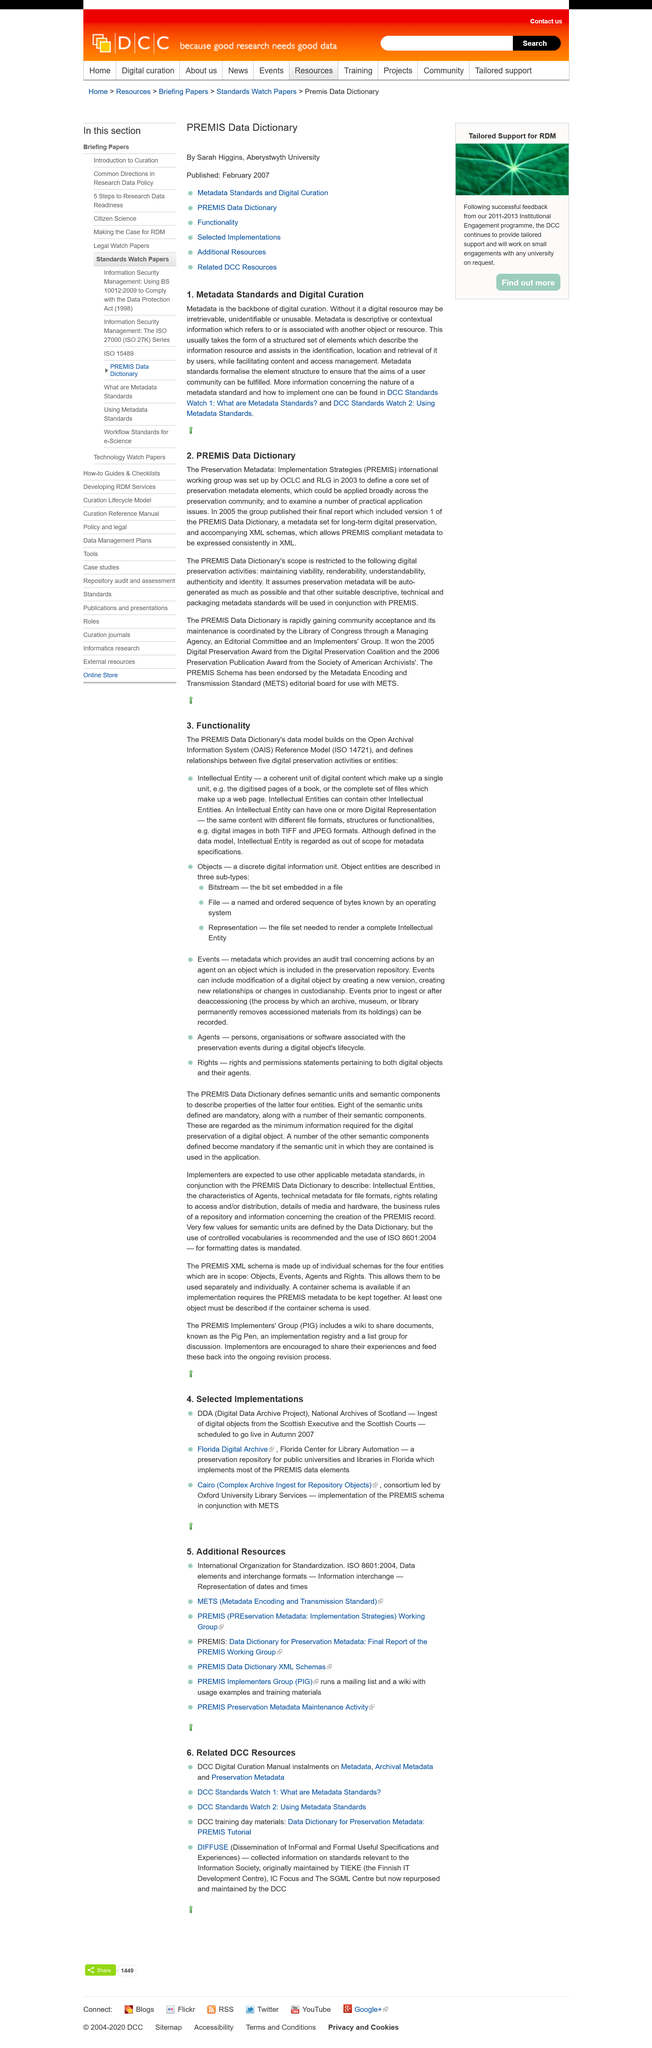Specify some key components in this picture. The source for acquiring additional information on metadata standards is DCC Standards Watch, which provides access to both version 1 and version 2. The lack of metadata in digital resources can result in their irretrievable, unidentifiable, or unused status. The subject of the topic is metadata standards and digital curation. 